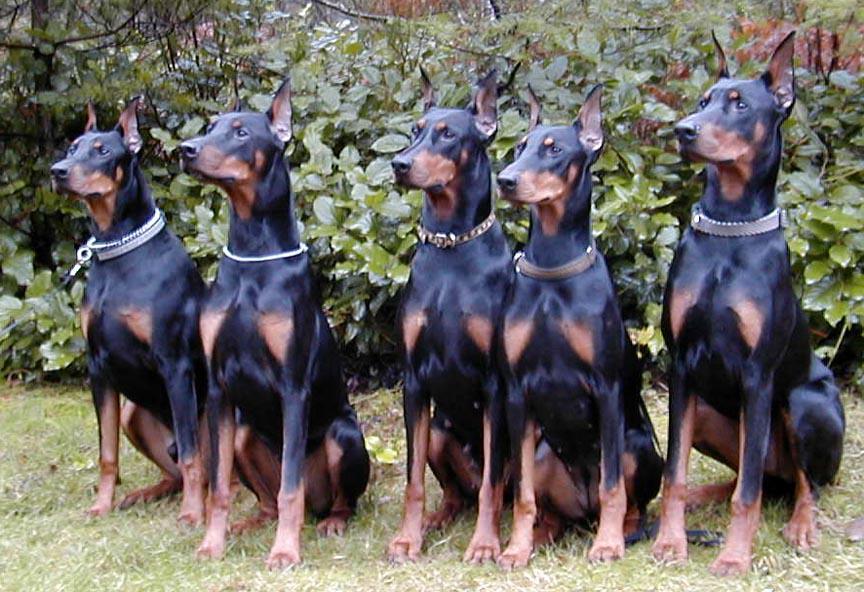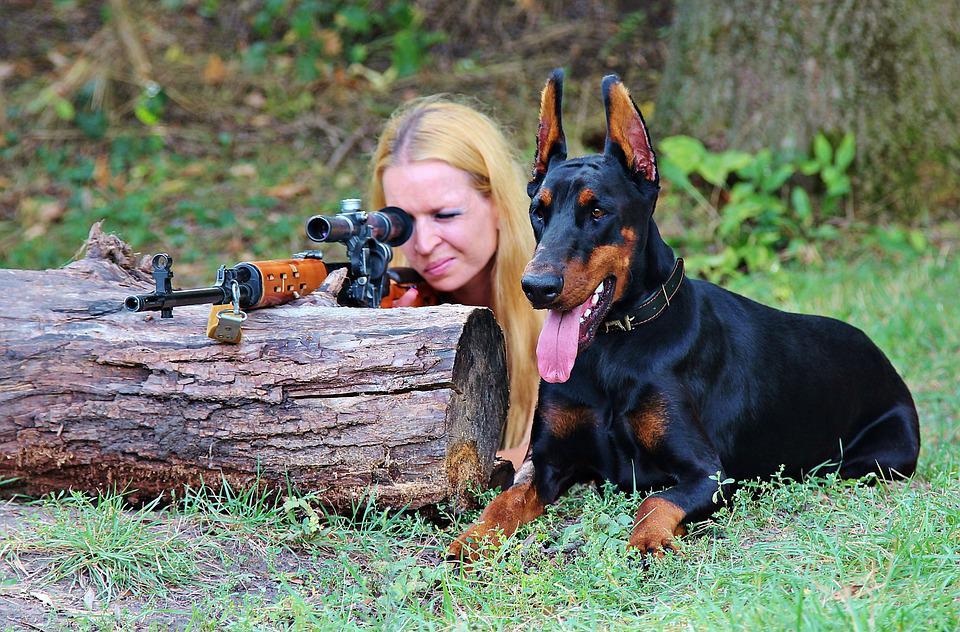The first image is the image on the left, the second image is the image on the right. Considering the images on both sides, is "there are 5 dogs sitting in a row on the grass while wearing collars" valid? Answer yes or no. Yes. 